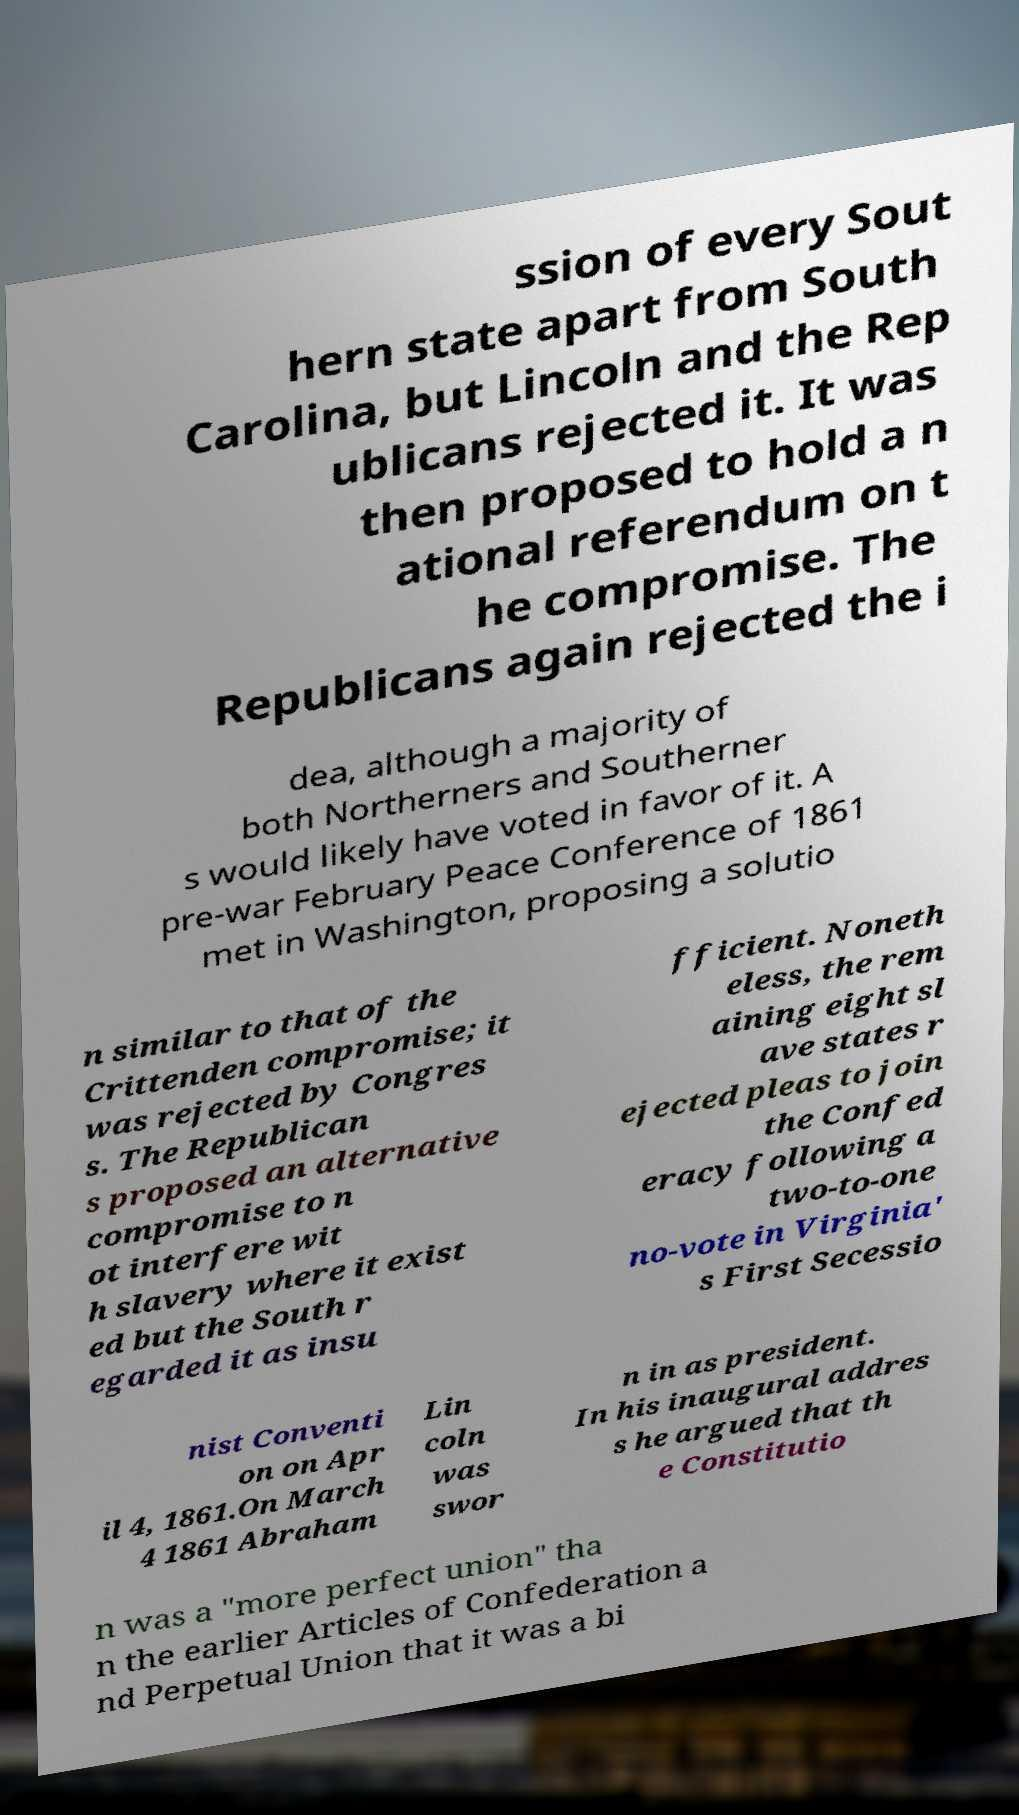There's text embedded in this image that I need extracted. Can you transcribe it verbatim? ssion of every Sout hern state apart from South Carolina, but Lincoln and the Rep ublicans rejected it. It was then proposed to hold a n ational referendum on t he compromise. The Republicans again rejected the i dea, although a majority of both Northerners and Southerner s would likely have voted in favor of it. A pre-war February Peace Conference of 1861 met in Washington, proposing a solutio n similar to that of the Crittenden compromise; it was rejected by Congres s. The Republican s proposed an alternative compromise to n ot interfere wit h slavery where it exist ed but the South r egarded it as insu fficient. Noneth eless, the rem aining eight sl ave states r ejected pleas to join the Confed eracy following a two-to-one no-vote in Virginia' s First Secessio nist Conventi on on Apr il 4, 1861.On March 4 1861 Abraham Lin coln was swor n in as president. In his inaugural addres s he argued that th e Constitutio n was a "more perfect union" tha n the earlier Articles of Confederation a nd Perpetual Union that it was a bi 